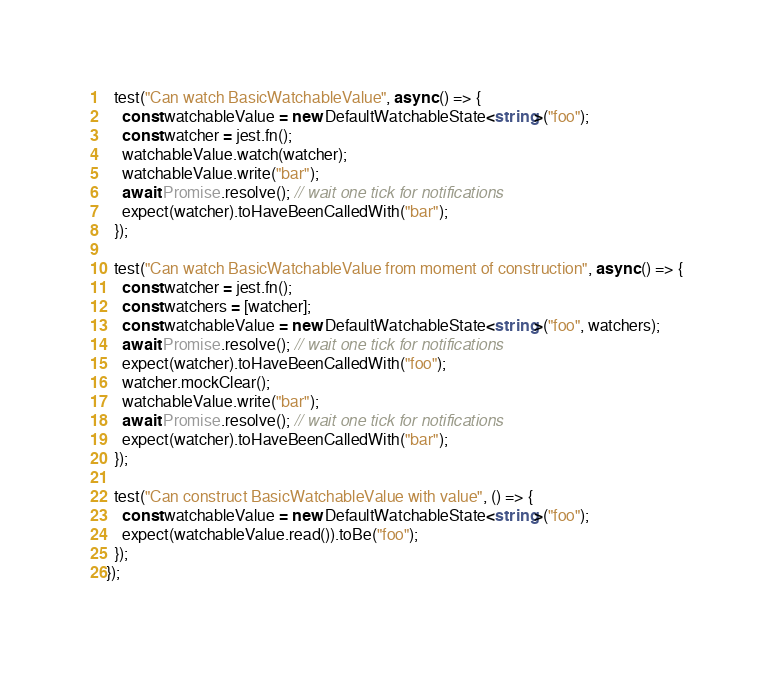Convert code to text. <code><loc_0><loc_0><loc_500><loc_500><_TypeScript_>
  test("Can watch BasicWatchableValue", async () => {
    const watchableValue = new DefaultWatchableState<string>("foo");
    const watcher = jest.fn();
    watchableValue.watch(watcher);
    watchableValue.write("bar");
    await Promise.resolve(); // wait one tick for notifications
    expect(watcher).toHaveBeenCalledWith("bar");
  });

  test("Can watch BasicWatchableValue from moment of construction", async () => {
    const watcher = jest.fn();
    const watchers = [watcher];
    const watchableValue = new DefaultWatchableState<string>("foo", watchers);
    await Promise.resolve(); // wait one tick for notifications
    expect(watcher).toHaveBeenCalledWith("foo");
    watcher.mockClear();
    watchableValue.write("bar");
    await Promise.resolve(); // wait one tick for notifications
    expect(watcher).toHaveBeenCalledWith("bar");
  });

  test("Can construct BasicWatchableValue with value", () => {
    const watchableValue = new DefaultWatchableState<string>("foo");
    expect(watchableValue.read()).toBe("foo");
  });
});
</code> 